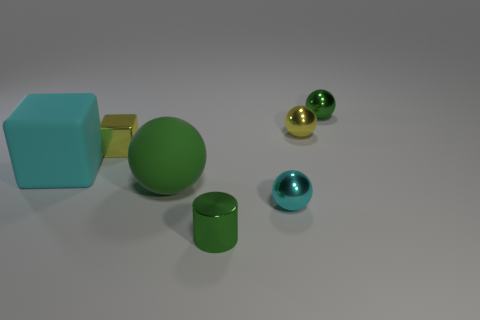Add 1 spheres. How many objects exist? 8 Subtract all red balls. Subtract all gray cylinders. How many balls are left? 4 Subtract all balls. How many objects are left? 3 Subtract all large cyan matte cylinders. Subtract all tiny cyan metallic things. How many objects are left? 6 Add 1 small balls. How many small balls are left? 4 Add 6 big yellow metal spheres. How many big yellow metal spheres exist? 6 Subtract 0 gray cylinders. How many objects are left? 7 